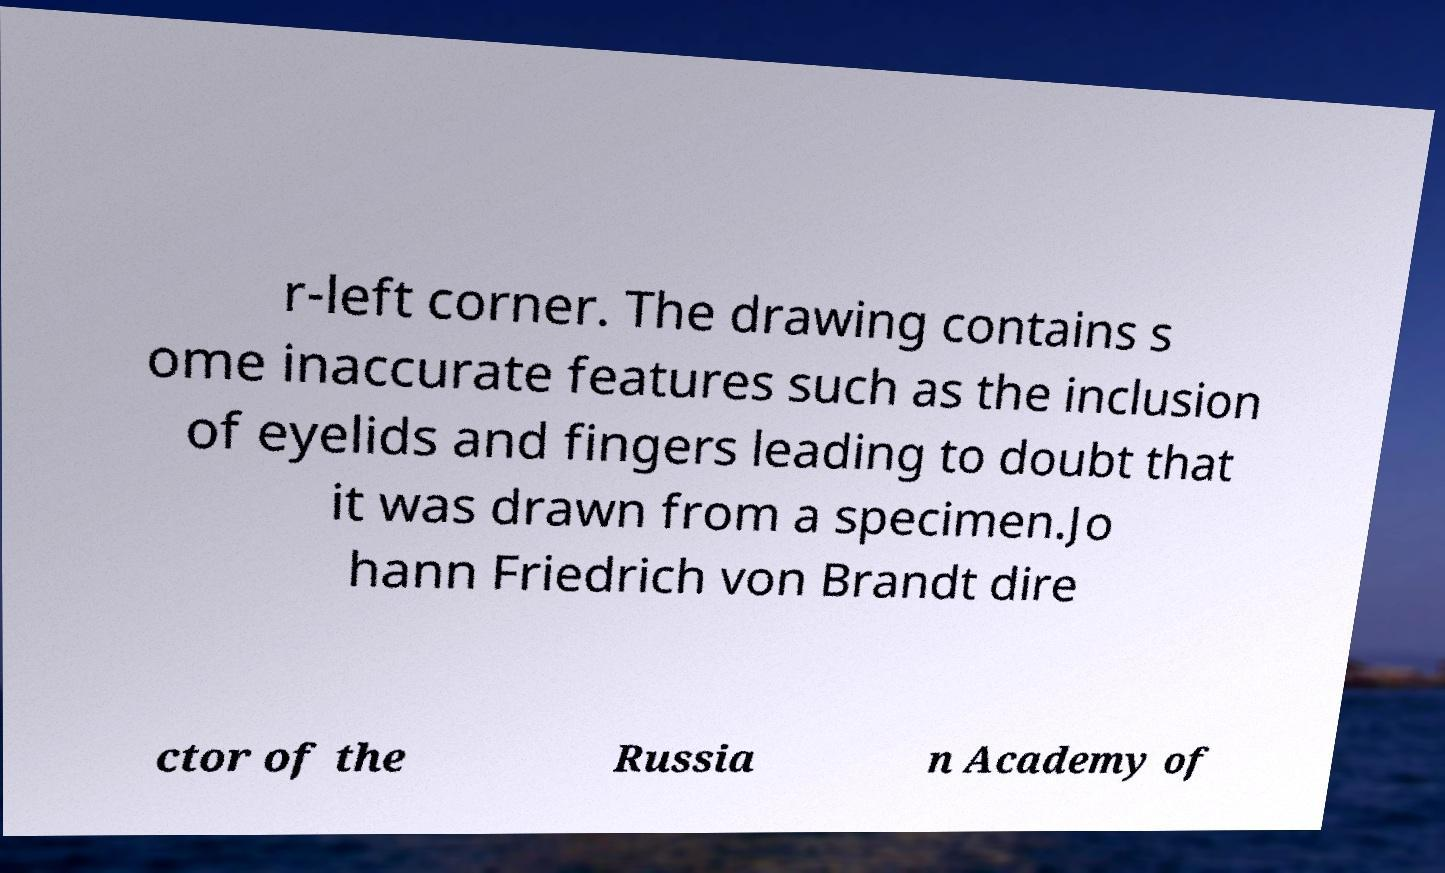Please identify and transcribe the text found in this image. r-left corner. The drawing contains s ome inaccurate features such as the inclusion of eyelids and fingers leading to doubt that it was drawn from a specimen.Jo hann Friedrich von Brandt dire ctor of the Russia n Academy of 